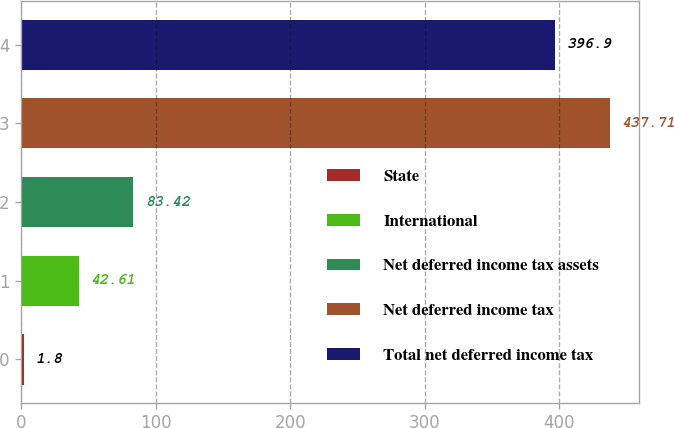<chart> <loc_0><loc_0><loc_500><loc_500><bar_chart><fcel>State<fcel>International<fcel>Net deferred income tax assets<fcel>Net deferred income tax<fcel>Total net deferred income tax<nl><fcel>1.8<fcel>42.61<fcel>83.42<fcel>437.71<fcel>396.9<nl></chart> 